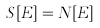<formula> <loc_0><loc_0><loc_500><loc_500>S [ E ] = N [ E ]</formula> 